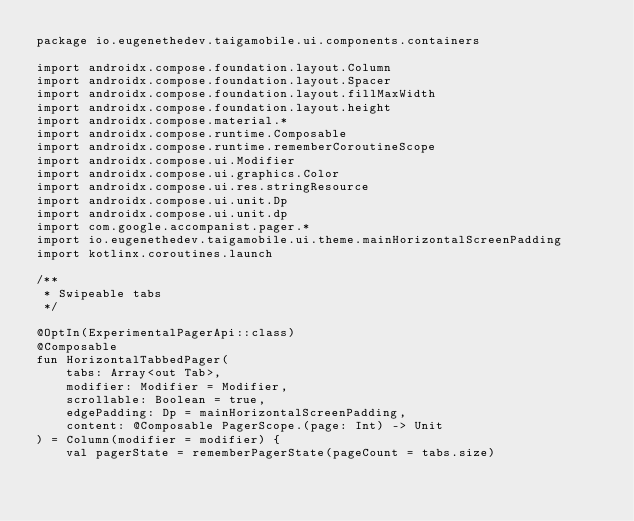<code> <loc_0><loc_0><loc_500><loc_500><_Kotlin_>package io.eugenethedev.taigamobile.ui.components.containers

import androidx.compose.foundation.layout.Column
import androidx.compose.foundation.layout.Spacer
import androidx.compose.foundation.layout.fillMaxWidth
import androidx.compose.foundation.layout.height
import androidx.compose.material.*
import androidx.compose.runtime.Composable
import androidx.compose.runtime.rememberCoroutineScope
import androidx.compose.ui.Modifier
import androidx.compose.ui.graphics.Color
import androidx.compose.ui.res.stringResource
import androidx.compose.ui.unit.Dp
import androidx.compose.ui.unit.dp
import com.google.accompanist.pager.*
import io.eugenethedev.taigamobile.ui.theme.mainHorizontalScreenPadding
import kotlinx.coroutines.launch

/**
 * Swipeable tabs
 */

@OptIn(ExperimentalPagerApi::class)
@Composable
fun HorizontalTabbedPager(
    tabs: Array<out Tab>,
    modifier: Modifier = Modifier,
    scrollable: Boolean = true,
    edgePadding: Dp = mainHorizontalScreenPadding,
    content: @Composable PagerScope.(page: Int) -> Unit
) = Column(modifier = modifier) {
    val pagerState = rememberPagerState(pageCount = tabs.size)</code> 